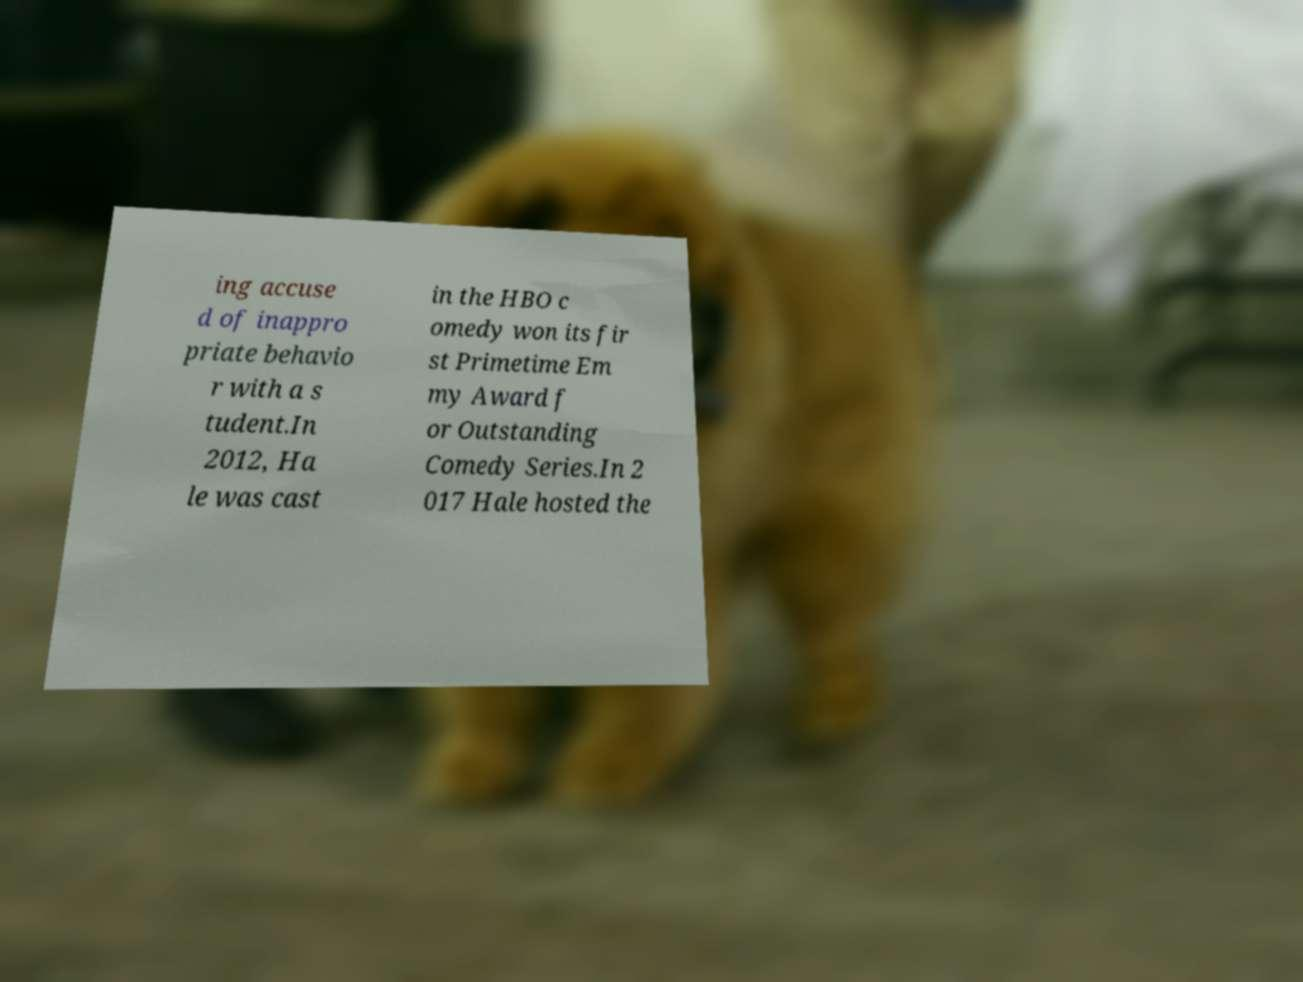Please identify and transcribe the text found in this image. ing accuse d of inappro priate behavio r with a s tudent.In 2012, Ha le was cast in the HBO c omedy won its fir st Primetime Em my Award f or Outstanding Comedy Series.In 2 017 Hale hosted the 